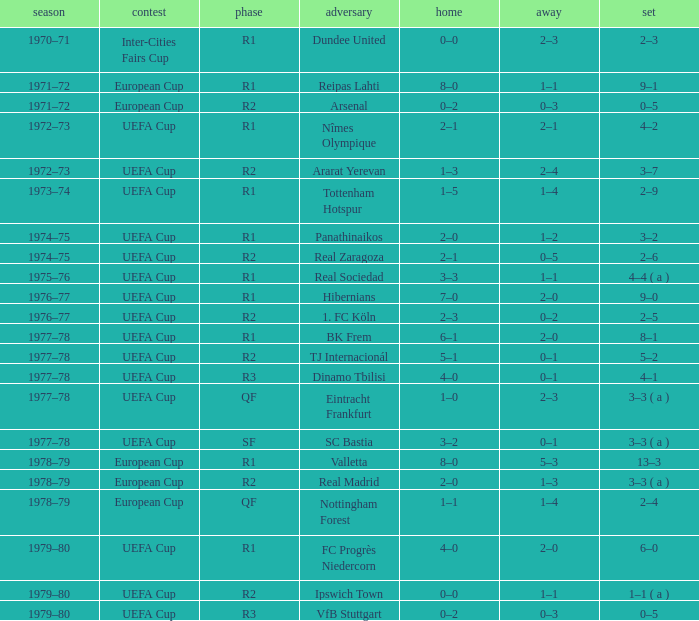Which Season has an Opponent of hibernians? 1976–77. 